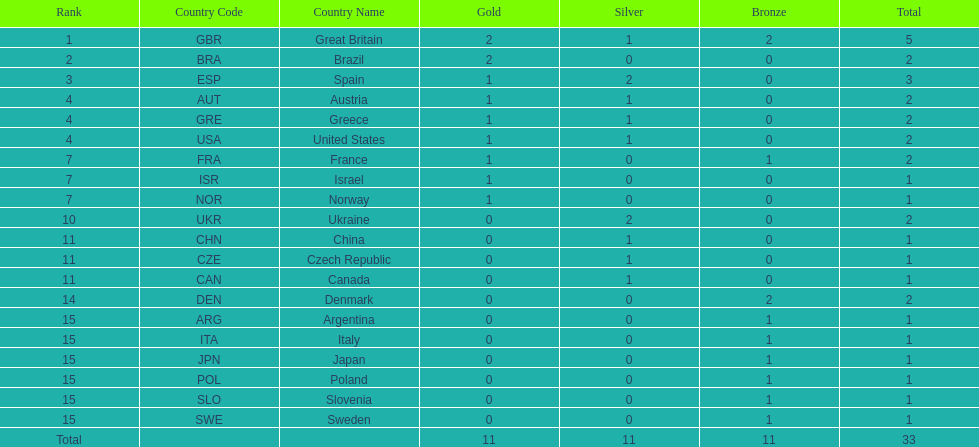Who won more gold medals than spain? Great Britain (GBR), Brazil (BRA). 